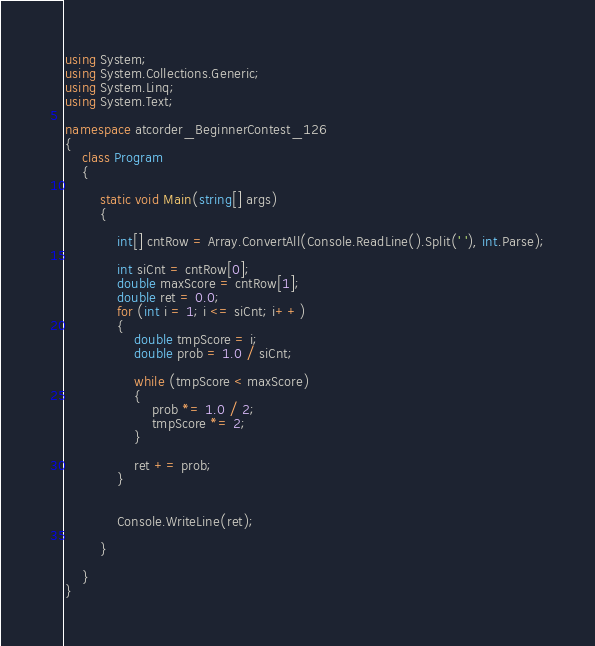<code> <loc_0><loc_0><loc_500><loc_500><_C#_>using System;
using System.Collections.Generic;
using System.Linq;
using System.Text;

namespace atcorder_BeginnerContest_126
{
    class Program
    {

        static void Main(string[] args)
        {

            int[] cntRow = Array.ConvertAll(Console.ReadLine().Split(' '), int.Parse);

            int siCnt = cntRow[0];
            double maxScore = cntRow[1];
            double ret = 0.0;
            for (int i = 1; i <= siCnt; i++)
            {
                double tmpScore = i;
                double prob = 1.0 / siCnt;

                while (tmpScore < maxScore)
                {
                    prob *= 1.0 / 2;
                    tmpScore *= 2;
                }

                ret += prob;
            }


            Console.WriteLine(ret);

        }

    }
}

</code> 